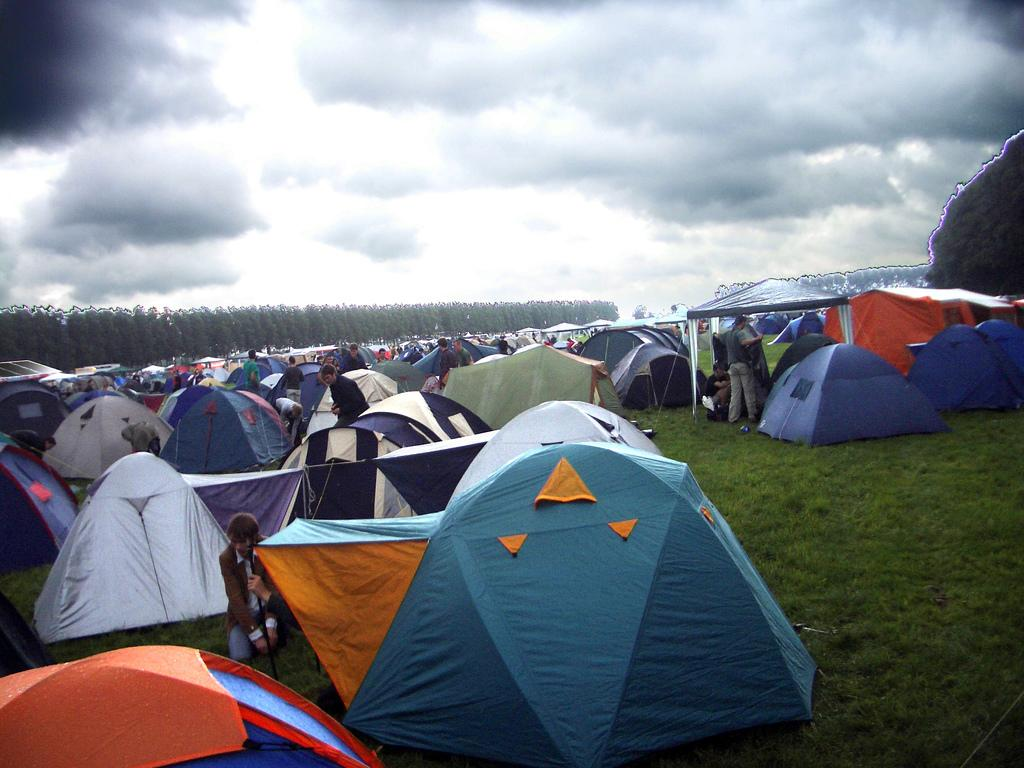What type of temporary shelters can be seen in the image? There are tents in the image. Who is present in the image? There is a group of people in the image. What type of vegetation is visible in the image? There are trees and grass in the image. What can be seen in the background of the image? The sky is visible in the background of the image. What type of canvas is being used to cover the shame of the people in the image? There is no mention of shame or canvas in the image; it features tents, a group of people, trees, grass, and the sky. How many wings can be seen on the people in the image? There are no wings visible on the people in the image. 